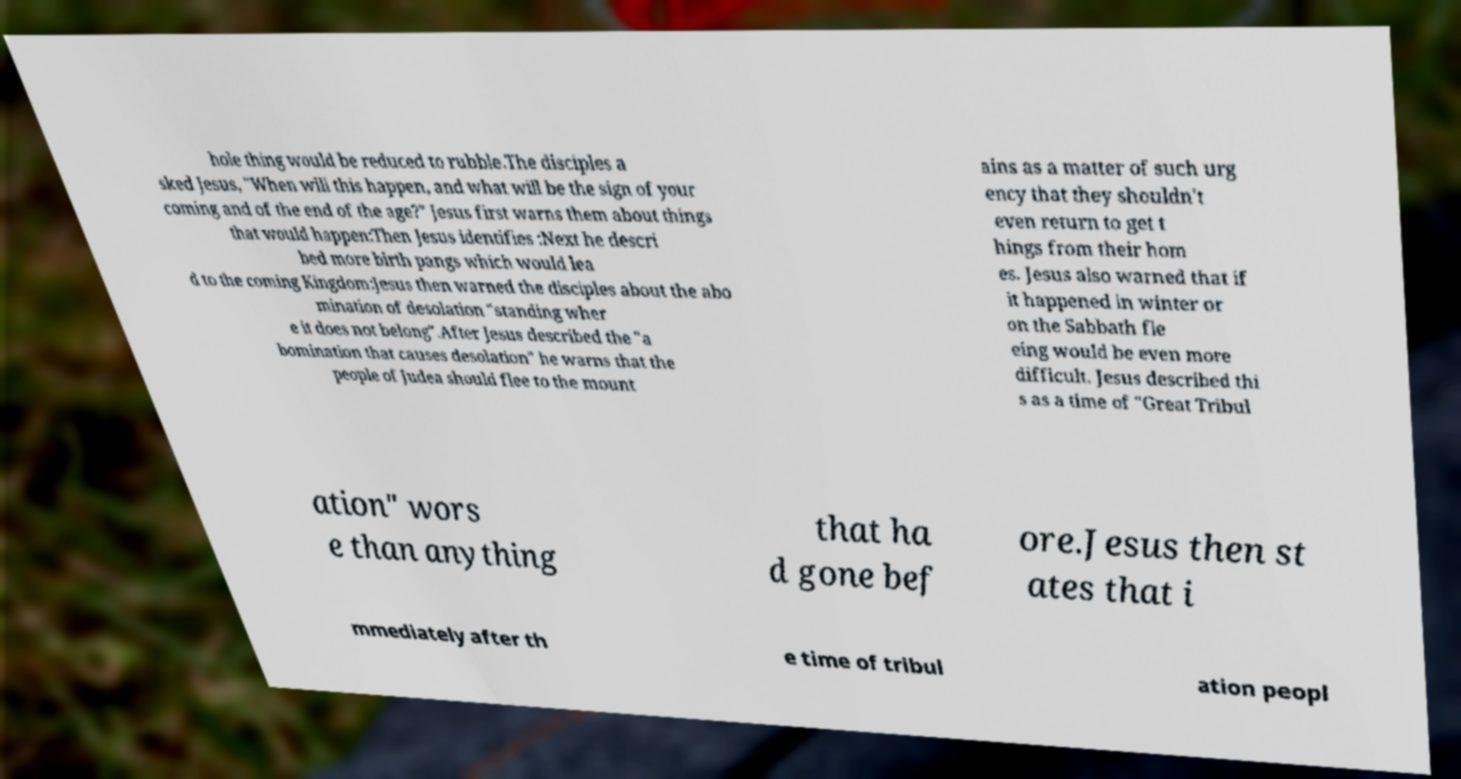Could you extract and type out the text from this image? hole thing would be reduced to rubble.The disciples a sked Jesus, "When will this happen, and what will be the sign of your coming and of the end of the age?" Jesus first warns them about things that would happen:Then Jesus identifies :Next he descri bed more birth pangs which would lea d to the coming Kingdom:Jesus then warned the disciples about the abo mination of desolation "standing wher e it does not belong".After Jesus described the "a bomination that causes desolation" he warns that the people of Judea should flee to the mount ains as a matter of such urg ency that they shouldn't even return to get t hings from their hom es. Jesus also warned that if it happened in winter or on the Sabbath fle eing would be even more difficult. Jesus described thi s as a time of "Great Tribul ation" wors e than anything that ha d gone bef ore.Jesus then st ates that i mmediately after th e time of tribul ation peopl 